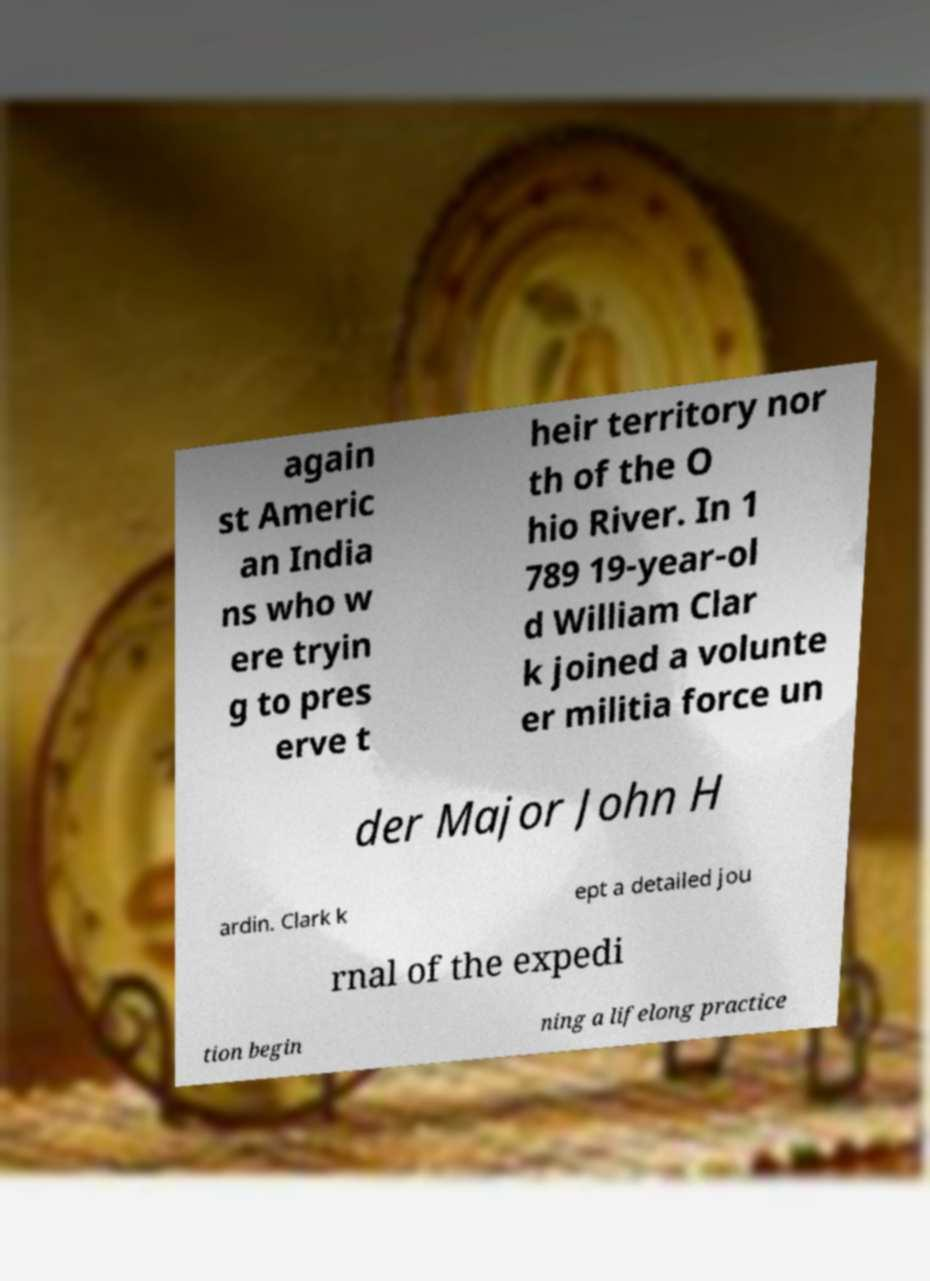Could you extract and type out the text from this image? again st Americ an India ns who w ere tryin g to pres erve t heir territory nor th of the O hio River. In 1 789 19-year-ol d William Clar k joined a volunte er militia force un der Major John H ardin. Clark k ept a detailed jou rnal of the expedi tion begin ning a lifelong practice 